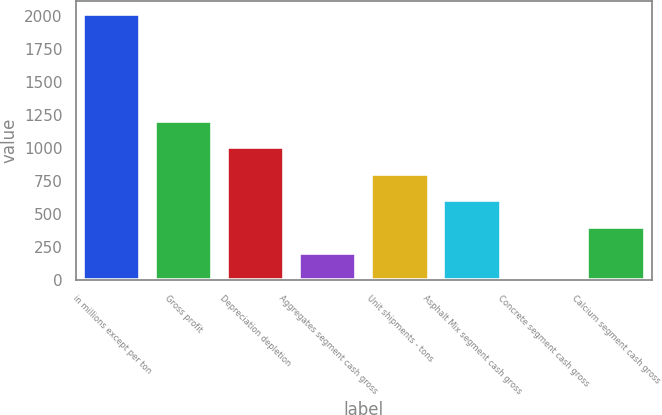Convert chart to OTSL. <chart><loc_0><loc_0><loc_500><loc_500><bar_chart><fcel>in millions except per ton<fcel>Gross profit<fcel>Depreciation depletion<fcel>Aggregates segment cash gross<fcel>Unit shipments - tons<fcel>Asphalt Mix segment cash gross<fcel>Concrete segment cash gross<fcel>Calcium segment cash gross<nl><fcel>2012<fcel>1208.44<fcel>1007.55<fcel>203.99<fcel>806.66<fcel>605.77<fcel>3.1<fcel>404.88<nl></chart> 